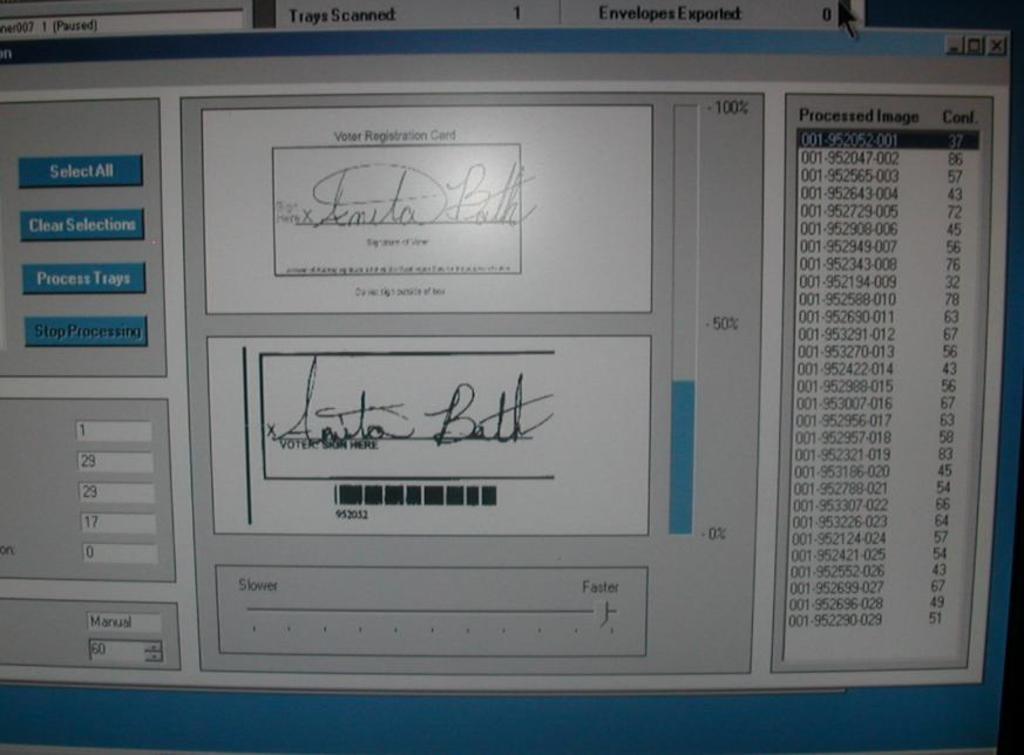What is the type of card?
Offer a very short reply. Voter registration. 